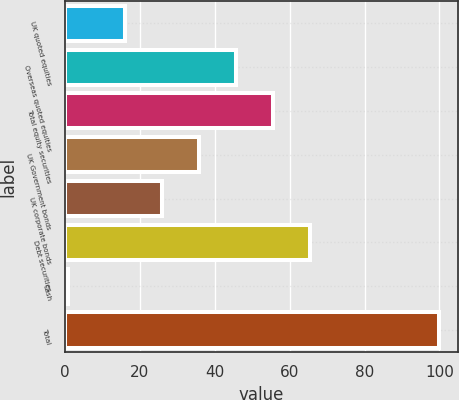<chart> <loc_0><loc_0><loc_500><loc_500><bar_chart><fcel>UK quoted equities<fcel>Overseas quoted equities<fcel>Total equity securities<fcel>UK Government bonds<fcel>UK corporate bonds<fcel>Debt securities<fcel>Cash<fcel>Total<nl><fcel>16<fcel>45.7<fcel>55.6<fcel>35.8<fcel>25.9<fcel>65.5<fcel>1<fcel>100<nl></chart> 